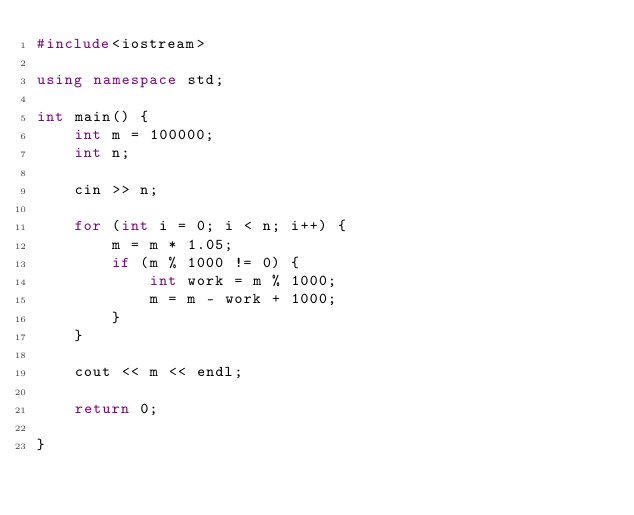Convert code to text. <code><loc_0><loc_0><loc_500><loc_500><_C++_>#include<iostream>

using namespace std;

int main() {
	int m = 100000;
	int n;

	cin >> n;

	for (int i = 0; i < n; i++) {
		m = m * 1.05;
		if (m % 1000 != 0) {
			int work = m % 1000;
			m = m - work + 1000;
		}
	}

	cout << m << endl;

	return 0;

}
</code> 